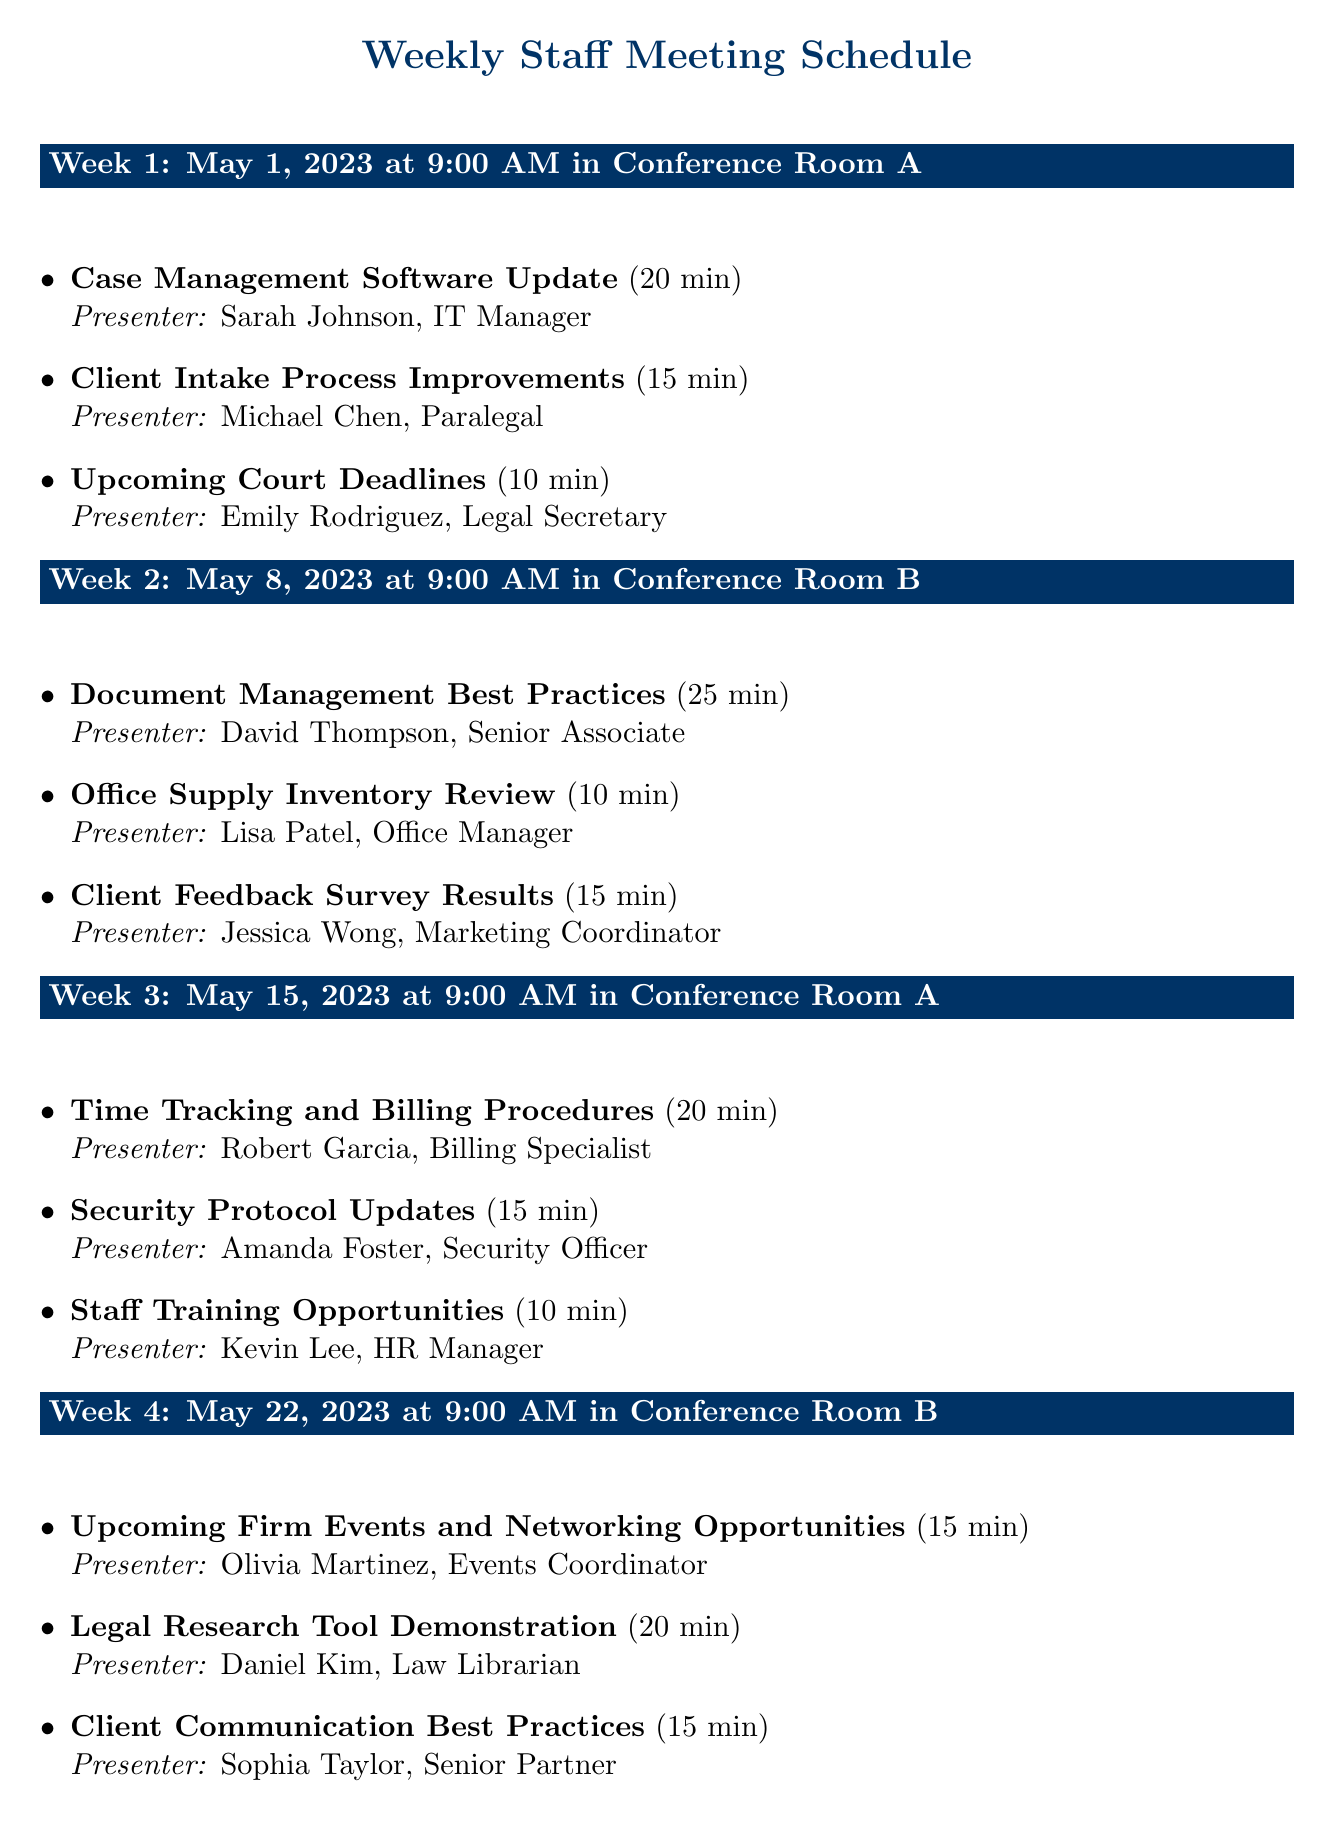what date is the week 2 meeting scheduled for? The date is specified in the schedule for week 2.
Answer: 2023-05-08 who is the presenter for "Client Intake Process Improvements"? The presenter is listed alongside the respective topic.
Answer: Michael Chen, Paralegal what is the total duration of topics presented in week 3? The total duration is calculated by adding the individual durations of the topics for that week.
Answer: 45 minutes which conference room is used for the week 1 meeting? The location is indicated in the schedule.
Answer: Conference Room A how many topics are presented in week 4? The number of topics is listed for week 4.
Answer: 3 topics what is the title of the topic presented by Jessica Wong? The title is identified alongside the presenter in the schedule.
Answer: Client Feedback Survey Results who will present the "Legal Research Tool Demonstration"? The presenter is mentioned with the corresponding topic title.
Answer: Daniel Kim, Law Librarian what is the time of the meetings scheduled for all weeks? The time is consistently mentioned for each week in the schedule.
Answer: 9:00 AM 